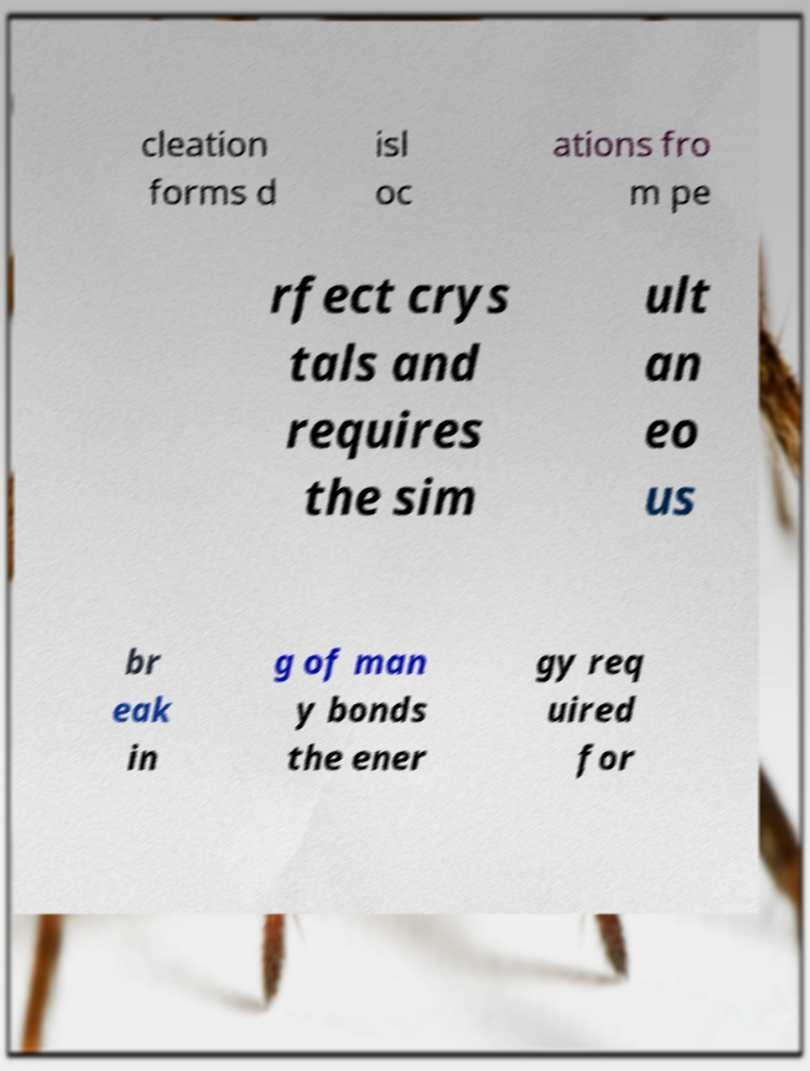Please read and relay the text visible in this image. What does it say? cleation forms d isl oc ations fro m pe rfect crys tals and requires the sim ult an eo us br eak in g of man y bonds the ener gy req uired for 